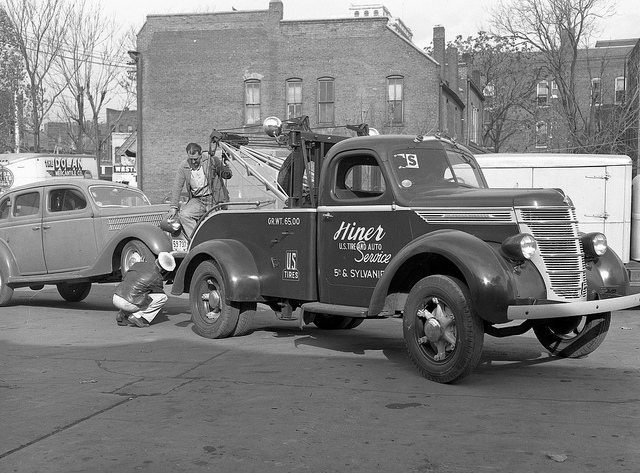<image>What type of engine does the truck on the left have? I don't know what type of engine the truck on the left has. It could be diesel, gas, gasoline, v6 or 450. What type of engine does the truck on the left have? I am not aware of what type of engine the truck on the left has. 